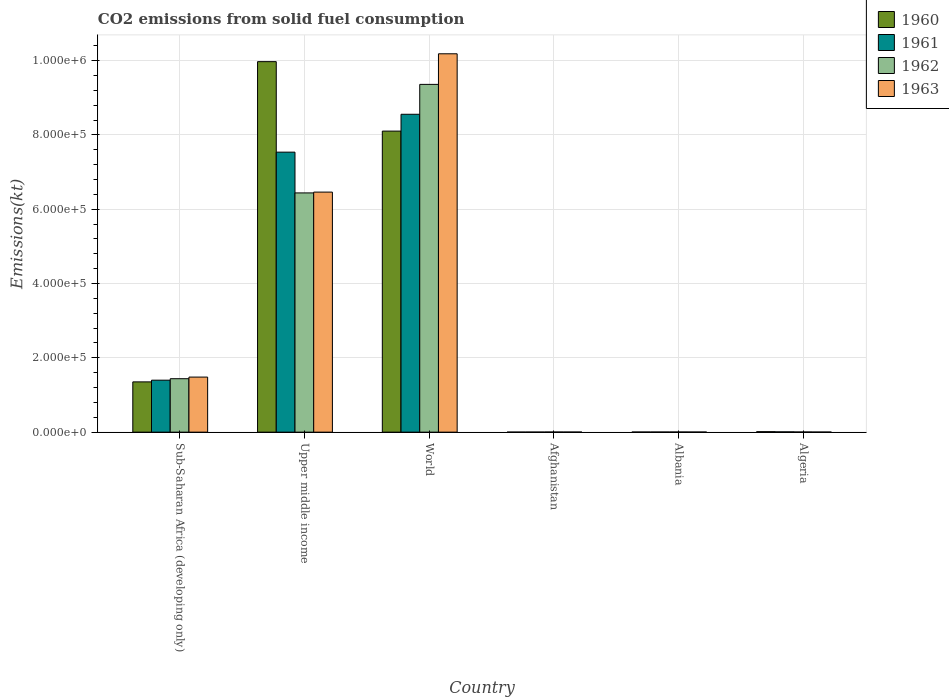How many bars are there on the 5th tick from the left?
Make the answer very short. 4. In how many cases, is the number of bars for a given country not equal to the number of legend labels?
Your answer should be compact. 0. What is the amount of CO2 emitted in 1962 in Upper middle income?
Make the answer very short. 6.44e+05. Across all countries, what is the maximum amount of CO2 emitted in 1961?
Make the answer very short. 8.56e+05. Across all countries, what is the minimum amount of CO2 emitted in 1962?
Your answer should be very brief. 297.03. In which country was the amount of CO2 emitted in 1960 maximum?
Offer a terse response. Upper middle income. In which country was the amount of CO2 emitted in 1963 minimum?
Your response must be concise. Algeria. What is the total amount of CO2 emitted in 1960 in the graph?
Offer a very short reply. 1.94e+06. What is the difference between the amount of CO2 emitted in 1960 in Albania and that in Sub-Saharan Africa (developing only)?
Your answer should be compact. -1.35e+05. What is the difference between the amount of CO2 emitted in 1962 in Afghanistan and the amount of CO2 emitted in 1963 in Algeria?
Give a very brief answer. 44. What is the average amount of CO2 emitted in 1960 per country?
Make the answer very short. 3.24e+05. What is the difference between the amount of CO2 emitted of/in 1961 and amount of CO2 emitted of/in 1963 in Afghanistan?
Your response must be concise. -88.01. What is the ratio of the amount of CO2 emitted in 1960 in Albania to that in Upper middle income?
Offer a very short reply. 0. Is the amount of CO2 emitted in 1961 in Algeria less than that in Sub-Saharan Africa (developing only)?
Your answer should be compact. Yes. What is the difference between the highest and the second highest amount of CO2 emitted in 1962?
Offer a very short reply. 7.92e+05. What is the difference between the highest and the lowest amount of CO2 emitted in 1961?
Your answer should be compact. 8.55e+05. In how many countries, is the amount of CO2 emitted in 1960 greater than the average amount of CO2 emitted in 1960 taken over all countries?
Your response must be concise. 2. Is the sum of the amount of CO2 emitted in 1961 in Albania and World greater than the maximum amount of CO2 emitted in 1963 across all countries?
Make the answer very short. No. Is it the case that in every country, the sum of the amount of CO2 emitted in 1962 and amount of CO2 emitted in 1963 is greater than the sum of amount of CO2 emitted in 1961 and amount of CO2 emitted in 1960?
Offer a terse response. No. What does the 4th bar from the left in Upper middle income represents?
Give a very brief answer. 1963. What does the 3rd bar from the right in Upper middle income represents?
Give a very brief answer. 1961. How many bars are there?
Provide a succinct answer. 24. How many countries are there in the graph?
Give a very brief answer. 6. How many legend labels are there?
Provide a succinct answer. 4. What is the title of the graph?
Make the answer very short. CO2 emissions from solid fuel consumption. What is the label or title of the Y-axis?
Provide a succinct answer. Emissions(kt). What is the Emissions(kt) in 1960 in Sub-Saharan Africa (developing only)?
Your answer should be very brief. 1.35e+05. What is the Emissions(kt) in 1961 in Sub-Saharan Africa (developing only)?
Provide a succinct answer. 1.40e+05. What is the Emissions(kt) in 1962 in Sub-Saharan Africa (developing only)?
Your response must be concise. 1.44e+05. What is the Emissions(kt) of 1963 in Sub-Saharan Africa (developing only)?
Your answer should be compact. 1.48e+05. What is the Emissions(kt) in 1960 in Upper middle income?
Keep it short and to the point. 9.97e+05. What is the Emissions(kt) of 1961 in Upper middle income?
Give a very brief answer. 7.54e+05. What is the Emissions(kt) in 1962 in Upper middle income?
Ensure brevity in your answer.  6.44e+05. What is the Emissions(kt) in 1963 in Upper middle income?
Make the answer very short. 6.46e+05. What is the Emissions(kt) of 1960 in World?
Your answer should be very brief. 8.10e+05. What is the Emissions(kt) in 1961 in World?
Your answer should be very brief. 8.56e+05. What is the Emissions(kt) in 1962 in World?
Provide a succinct answer. 9.36e+05. What is the Emissions(kt) of 1963 in World?
Offer a terse response. 1.02e+06. What is the Emissions(kt) of 1960 in Afghanistan?
Ensure brevity in your answer.  128.34. What is the Emissions(kt) in 1961 in Afghanistan?
Provide a short and direct response. 176.02. What is the Emissions(kt) in 1962 in Afghanistan?
Offer a very short reply. 297.03. What is the Emissions(kt) in 1963 in Afghanistan?
Make the answer very short. 264.02. What is the Emissions(kt) in 1960 in Albania?
Offer a very short reply. 326.36. What is the Emissions(kt) of 1961 in Albania?
Offer a terse response. 322.7. What is the Emissions(kt) in 1962 in Albania?
Provide a succinct answer. 363.03. What is the Emissions(kt) in 1963 in Albania?
Your answer should be very brief. 282.36. What is the Emissions(kt) in 1960 in Algeria?
Offer a very short reply. 1257.78. What is the Emissions(kt) in 1961 in Algeria?
Provide a succinct answer. 766.4. What is the Emissions(kt) in 1962 in Algeria?
Offer a terse response. 407.04. What is the Emissions(kt) in 1963 in Algeria?
Your answer should be very brief. 253.02. Across all countries, what is the maximum Emissions(kt) of 1960?
Make the answer very short. 9.97e+05. Across all countries, what is the maximum Emissions(kt) in 1961?
Offer a terse response. 8.56e+05. Across all countries, what is the maximum Emissions(kt) of 1962?
Offer a terse response. 9.36e+05. Across all countries, what is the maximum Emissions(kt) of 1963?
Offer a terse response. 1.02e+06. Across all countries, what is the minimum Emissions(kt) of 1960?
Provide a short and direct response. 128.34. Across all countries, what is the minimum Emissions(kt) of 1961?
Make the answer very short. 176.02. Across all countries, what is the minimum Emissions(kt) of 1962?
Your answer should be very brief. 297.03. Across all countries, what is the minimum Emissions(kt) in 1963?
Your answer should be compact. 253.02. What is the total Emissions(kt) of 1960 in the graph?
Your response must be concise. 1.94e+06. What is the total Emissions(kt) of 1961 in the graph?
Your response must be concise. 1.75e+06. What is the total Emissions(kt) of 1962 in the graph?
Offer a very short reply. 1.72e+06. What is the total Emissions(kt) in 1963 in the graph?
Offer a very short reply. 1.81e+06. What is the difference between the Emissions(kt) in 1960 in Sub-Saharan Africa (developing only) and that in Upper middle income?
Your answer should be very brief. -8.62e+05. What is the difference between the Emissions(kt) in 1961 in Sub-Saharan Africa (developing only) and that in Upper middle income?
Provide a short and direct response. -6.14e+05. What is the difference between the Emissions(kt) of 1962 in Sub-Saharan Africa (developing only) and that in Upper middle income?
Offer a terse response. -5.00e+05. What is the difference between the Emissions(kt) of 1963 in Sub-Saharan Africa (developing only) and that in Upper middle income?
Offer a very short reply. -4.98e+05. What is the difference between the Emissions(kt) of 1960 in Sub-Saharan Africa (developing only) and that in World?
Offer a terse response. -6.75e+05. What is the difference between the Emissions(kt) of 1961 in Sub-Saharan Africa (developing only) and that in World?
Give a very brief answer. -7.16e+05. What is the difference between the Emissions(kt) in 1962 in Sub-Saharan Africa (developing only) and that in World?
Offer a very short reply. -7.92e+05. What is the difference between the Emissions(kt) of 1963 in Sub-Saharan Africa (developing only) and that in World?
Ensure brevity in your answer.  -8.70e+05. What is the difference between the Emissions(kt) in 1960 in Sub-Saharan Africa (developing only) and that in Afghanistan?
Your answer should be very brief. 1.35e+05. What is the difference between the Emissions(kt) of 1961 in Sub-Saharan Africa (developing only) and that in Afghanistan?
Give a very brief answer. 1.40e+05. What is the difference between the Emissions(kt) in 1962 in Sub-Saharan Africa (developing only) and that in Afghanistan?
Your response must be concise. 1.44e+05. What is the difference between the Emissions(kt) in 1963 in Sub-Saharan Africa (developing only) and that in Afghanistan?
Your response must be concise. 1.48e+05. What is the difference between the Emissions(kt) of 1960 in Sub-Saharan Africa (developing only) and that in Albania?
Offer a terse response. 1.35e+05. What is the difference between the Emissions(kt) in 1961 in Sub-Saharan Africa (developing only) and that in Albania?
Offer a terse response. 1.40e+05. What is the difference between the Emissions(kt) of 1962 in Sub-Saharan Africa (developing only) and that in Albania?
Your answer should be very brief. 1.43e+05. What is the difference between the Emissions(kt) in 1963 in Sub-Saharan Africa (developing only) and that in Albania?
Give a very brief answer. 1.48e+05. What is the difference between the Emissions(kt) in 1960 in Sub-Saharan Africa (developing only) and that in Algeria?
Make the answer very short. 1.34e+05. What is the difference between the Emissions(kt) of 1961 in Sub-Saharan Africa (developing only) and that in Algeria?
Offer a very short reply. 1.39e+05. What is the difference between the Emissions(kt) of 1962 in Sub-Saharan Africa (developing only) and that in Algeria?
Give a very brief answer. 1.43e+05. What is the difference between the Emissions(kt) in 1963 in Sub-Saharan Africa (developing only) and that in Algeria?
Your response must be concise. 1.48e+05. What is the difference between the Emissions(kt) of 1960 in Upper middle income and that in World?
Your response must be concise. 1.87e+05. What is the difference between the Emissions(kt) of 1961 in Upper middle income and that in World?
Offer a terse response. -1.02e+05. What is the difference between the Emissions(kt) in 1962 in Upper middle income and that in World?
Offer a terse response. -2.92e+05. What is the difference between the Emissions(kt) of 1963 in Upper middle income and that in World?
Give a very brief answer. -3.72e+05. What is the difference between the Emissions(kt) in 1960 in Upper middle income and that in Afghanistan?
Your answer should be very brief. 9.97e+05. What is the difference between the Emissions(kt) in 1961 in Upper middle income and that in Afghanistan?
Provide a short and direct response. 7.53e+05. What is the difference between the Emissions(kt) in 1962 in Upper middle income and that in Afghanistan?
Your answer should be very brief. 6.44e+05. What is the difference between the Emissions(kt) in 1963 in Upper middle income and that in Afghanistan?
Ensure brevity in your answer.  6.46e+05. What is the difference between the Emissions(kt) in 1960 in Upper middle income and that in Albania?
Provide a short and direct response. 9.97e+05. What is the difference between the Emissions(kt) of 1961 in Upper middle income and that in Albania?
Offer a very short reply. 7.53e+05. What is the difference between the Emissions(kt) of 1962 in Upper middle income and that in Albania?
Provide a succinct answer. 6.44e+05. What is the difference between the Emissions(kt) in 1963 in Upper middle income and that in Albania?
Offer a very short reply. 6.46e+05. What is the difference between the Emissions(kt) in 1960 in Upper middle income and that in Algeria?
Offer a terse response. 9.96e+05. What is the difference between the Emissions(kt) of 1961 in Upper middle income and that in Algeria?
Your answer should be very brief. 7.53e+05. What is the difference between the Emissions(kt) of 1962 in Upper middle income and that in Algeria?
Offer a terse response. 6.44e+05. What is the difference between the Emissions(kt) in 1963 in Upper middle income and that in Algeria?
Ensure brevity in your answer.  6.46e+05. What is the difference between the Emissions(kt) of 1960 in World and that in Afghanistan?
Offer a terse response. 8.10e+05. What is the difference between the Emissions(kt) of 1961 in World and that in Afghanistan?
Offer a very short reply. 8.55e+05. What is the difference between the Emissions(kt) of 1962 in World and that in Afghanistan?
Give a very brief answer. 9.36e+05. What is the difference between the Emissions(kt) of 1963 in World and that in Afghanistan?
Offer a very short reply. 1.02e+06. What is the difference between the Emissions(kt) in 1960 in World and that in Albania?
Offer a terse response. 8.10e+05. What is the difference between the Emissions(kt) in 1961 in World and that in Albania?
Offer a terse response. 8.55e+05. What is the difference between the Emissions(kt) of 1962 in World and that in Albania?
Give a very brief answer. 9.36e+05. What is the difference between the Emissions(kt) of 1963 in World and that in Albania?
Keep it short and to the point. 1.02e+06. What is the difference between the Emissions(kt) of 1960 in World and that in Algeria?
Provide a succinct answer. 8.09e+05. What is the difference between the Emissions(kt) of 1961 in World and that in Algeria?
Your answer should be very brief. 8.55e+05. What is the difference between the Emissions(kt) in 1962 in World and that in Algeria?
Provide a short and direct response. 9.36e+05. What is the difference between the Emissions(kt) of 1963 in World and that in Algeria?
Your answer should be compact. 1.02e+06. What is the difference between the Emissions(kt) of 1960 in Afghanistan and that in Albania?
Keep it short and to the point. -198.02. What is the difference between the Emissions(kt) of 1961 in Afghanistan and that in Albania?
Your response must be concise. -146.68. What is the difference between the Emissions(kt) in 1962 in Afghanistan and that in Albania?
Your answer should be compact. -66.01. What is the difference between the Emissions(kt) of 1963 in Afghanistan and that in Albania?
Your answer should be compact. -18.34. What is the difference between the Emissions(kt) in 1960 in Afghanistan and that in Algeria?
Ensure brevity in your answer.  -1129.44. What is the difference between the Emissions(kt) of 1961 in Afghanistan and that in Algeria?
Give a very brief answer. -590.39. What is the difference between the Emissions(kt) of 1962 in Afghanistan and that in Algeria?
Your answer should be very brief. -110.01. What is the difference between the Emissions(kt) in 1963 in Afghanistan and that in Algeria?
Give a very brief answer. 11. What is the difference between the Emissions(kt) in 1960 in Albania and that in Algeria?
Make the answer very short. -931.42. What is the difference between the Emissions(kt) in 1961 in Albania and that in Algeria?
Provide a succinct answer. -443.71. What is the difference between the Emissions(kt) in 1962 in Albania and that in Algeria?
Your answer should be very brief. -44. What is the difference between the Emissions(kt) of 1963 in Albania and that in Algeria?
Keep it short and to the point. 29.34. What is the difference between the Emissions(kt) in 1960 in Sub-Saharan Africa (developing only) and the Emissions(kt) in 1961 in Upper middle income?
Offer a terse response. -6.18e+05. What is the difference between the Emissions(kt) in 1960 in Sub-Saharan Africa (developing only) and the Emissions(kt) in 1962 in Upper middle income?
Keep it short and to the point. -5.09e+05. What is the difference between the Emissions(kt) in 1960 in Sub-Saharan Africa (developing only) and the Emissions(kt) in 1963 in Upper middle income?
Provide a succinct answer. -5.11e+05. What is the difference between the Emissions(kt) in 1961 in Sub-Saharan Africa (developing only) and the Emissions(kt) in 1962 in Upper middle income?
Your answer should be compact. -5.04e+05. What is the difference between the Emissions(kt) in 1961 in Sub-Saharan Africa (developing only) and the Emissions(kt) in 1963 in Upper middle income?
Ensure brevity in your answer.  -5.06e+05. What is the difference between the Emissions(kt) of 1962 in Sub-Saharan Africa (developing only) and the Emissions(kt) of 1963 in Upper middle income?
Your answer should be compact. -5.02e+05. What is the difference between the Emissions(kt) in 1960 in Sub-Saharan Africa (developing only) and the Emissions(kt) in 1961 in World?
Ensure brevity in your answer.  -7.20e+05. What is the difference between the Emissions(kt) in 1960 in Sub-Saharan Africa (developing only) and the Emissions(kt) in 1962 in World?
Your response must be concise. -8.01e+05. What is the difference between the Emissions(kt) of 1960 in Sub-Saharan Africa (developing only) and the Emissions(kt) of 1963 in World?
Offer a very short reply. -8.83e+05. What is the difference between the Emissions(kt) of 1961 in Sub-Saharan Africa (developing only) and the Emissions(kt) of 1962 in World?
Keep it short and to the point. -7.96e+05. What is the difference between the Emissions(kt) in 1961 in Sub-Saharan Africa (developing only) and the Emissions(kt) in 1963 in World?
Provide a succinct answer. -8.79e+05. What is the difference between the Emissions(kt) in 1962 in Sub-Saharan Africa (developing only) and the Emissions(kt) in 1963 in World?
Keep it short and to the point. -8.75e+05. What is the difference between the Emissions(kt) in 1960 in Sub-Saharan Africa (developing only) and the Emissions(kt) in 1961 in Afghanistan?
Offer a very short reply. 1.35e+05. What is the difference between the Emissions(kt) of 1960 in Sub-Saharan Africa (developing only) and the Emissions(kt) of 1962 in Afghanistan?
Give a very brief answer. 1.35e+05. What is the difference between the Emissions(kt) in 1960 in Sub-Saharan Africa (developing only) and the Emissions(kt) in 1963 in Afghanistan?
Your response must be concise. 1.35e+05. What is the difference between the Emissions(kt) in 1961 in Sub-Saharan Africa (developing only) and the Emissions(kt) in 1962 in Afghanistan?
Your answer should be compact. 1.40e+05. What is the difference between the Emissions(kt) of 1961 in Sub-Saharan Africa (developing only) and the Emissions(kt) of 1963 in Afghanistan?
Your answer should be very brief. 1.40e+05. What is the difference between the Emissions(kt) of 1962 in Sub-Saharan Africa (developing only) and the Emissions(kt) of 1963 in Afghanistan?
Ensure brevity in your answer.  1.44e+05. What is the difference between the Emissions(kt) in 1960 in Sub-Saharan Africa (developing only) and the Emissions(kt) in 1961 in Albania?
Provide a short and direct response. 1.35e+05. What is the difference between the Emissions(kt) in 1960 in Sub-Saharan Africa (developing only) and the Emissions(kt) in 1962 in Albania?
Provide a short and direct response. 1.35e+05. What is the difference between the Emissions(kt) in 1960 in Sub-Saharan Africa (developing only) and the Emissions(kt) in 1963 in Albania?
Your answer should be very brief. 1.35e+05. What is the difference between the Emissions(kt) of 1961 in Sub-Saharan Africa (developing only) and the Emissions(kt) of 1962 in Albania?
Keep it short and to the point. 1.40e+05. What is the difference between the Emissions(kt) of 1961 in Sub-Saharan Africa (developing only) and the Emissions(kt) of 1963 in Albania?
Give a very brief answer. 1.40e+05. What is the difference between the Emissions(kt) of 1962 in Sub-Saharan Africa (developing only) and the Emissions(kt) of 1963 in Albania?
Make the answer very short. 1.44e+05. What is the difference between the Emissions(kt) in 1960 in Sub-Saharan Africa (developing only) and the Emissions(kt) in 1961 in Algeria?
Your response must be concise. 1.35e+05. What is the difference between the Emissions(kt) of 1960 in Sub-Saharan Africa (developing only) and the Emissions(kt) of 1962 in Algeria?
Ensure brevity in your answer.  1.35e+05. What is the difference between the Emissions(kt) of 1960 in Sub-Saharan Africa (developing only) and the Emissions(kt) of 1963 in Algeria?
Ensure brevity in your answer.  1.35e+05. What is the difference between the Emissions(kt) in 1961 in Sub-Saharan Africa (developing only) and the Emissions(kt) in 1962 in Algeria?
Provide a short and direct response. 1.39e+05. What is the difference between the Emissions(kt) of 1961 in Sub-Saharan Africa (developing only) and the Emissions(kt) of 1963 in Algeria?
Your answer should be compact. 1.40e+05. What is the difference between the Emissions(kt) of 1962 in Sub-Saharan Africa (developing only) and the Emissions(kt) of 1963 in Algeria?
Make the answer very short. 1.44e+05. What is the difference between the Emissions(kt) in 1960 in Upper middle income and the Emissions(kt) in 1961 in World?
Offer a very short reply. 1.42e+05. What is the difference between the Emissions(kt) in 1960 in Upper middle income and the Emissions(kt) in 1962 in World?
Your answer should be compact. 6.12e+04. What is the difference between the Emissions(kt) of 1960 in Upper middle income and the Emissions(kt) of 1963 in World?
Offer a terse response. -2.12e+04. What is the difference between the Emissions(kt) in 1961 in Upper middle income and the Emissions(kt) in 1962 in World?
Offer a very short reply. -1.82e+05. What is the difference between the Emissions(kt) of 1961 in Upper middle income and the Emissions(kt) of 1963 in World?
Provide a short and direct response. -2.65e+05. What is the difference between the Emissions(kt) in 1962 in Upper middle income and the Emissions(kt) in 1963 in World?
Provide a succinct answer. -3.74e+05. What is the difference between the Emissions(kt) in 1960 in Upper middle income and the Emissions(kt) in 1961 in Afghanistan?
Your answer should be very brief. 9.97e+05. What is the difference between the Emissions(kt) of 1960 in Upper middle income and the Emissions(kt) of 1962 in Afghanistan?
Offer a very short reply. 9.97e+05. What is the difference between the Emissions(kt) in 1960 in Upper middle income and the Emissions(kt) in 1963 in Afghanistan?
Give a very brief answer. 9.97e+05. What is the difference between the Emissions(kt) of 1961 in Upper middle income and the Emissions(kt) of 1962 in Afghanistan?
Give a very brief answer. 7.53e+05. What is the difference between the Emissions(kt) of 1961 in Upper middle income and the Emissions(kt) of 1963 in Afghanistan?
Your answer should be very brief. 7.53e+05. What is the difference between the Emissions(kt) in 1962 in Upper middle income and the Emissions(kt) in 1963 in Afghanistan?
Offer a very short reply. 6.44e+05. What is the difference between the Emissions(kt) in 1960 in Upper middle income and the Emissions(kt) in 1961 in Albania?
Your answer should be compact. 9.97e+05. What is the difference between the Emissions(kt) in 1960 in Upper middle income and the Emissions(kt) in 1962 in Albania?
Give a very brief answer. 9.97e+05. What is the difference between the Emissions(kt) of 1960 in Upper middle income and the Emissions(kt) of 1963 in Albania?
Your answer should be compact. 9.97e+05. What is the difference between the Emissions(kt) in 1961 in Upper middle income and the Emissions(kt) in 1962 in Albania?
Your answer should be very brief. 7.53e+05. What is the difference between the Emissions(kt) in 1961 in Upper middle income and the Emissions(kt) in 1963 in Albania?
Provide a short and direct response. 7.53e+05. What is the difference between the Emissions(kt) in 1962 in Upper middle income and the Emissions(kt) in 1963 in Albania?
Offer a terse response. 6.44e+05. What is the difference between the Emissions(kt) of 1960 in Upper middle income and the Emissions(kt) of 1961 in Algeria?
Ensure brevity in your answer.  9.97e+05. What is the difference between the Emissions(kt) in 1960 in Upper middle income and the Emissions(kt) in 1962 in Algeria?
Keep it short and to the point. 9.97e+05. What is the difference between the Emissions(kt) of 1960 in Upper middle income and the Emissions(kt) of 1963 in Algeria?
Provide a succinct answer. 9.97e+05. What is the difference between the Emissions(kt) of 1961 in Upper middle income and the Emissions(kt) of 1962 in Algeria?
Ensure brevity in your answer.  7.53e+05. What is the difference between the Emissions(kt) of 1961 in Upper middle income and the Emissions(kt) of 1963 in Algeria?
Keep it short and to the point. 7.53e+05. What is the difference between the Emissions(kt) in 1962 in Upper middle income and the Emissions(kt) in 1963 in Algeria?
Make the answer very short. 6.44e+05. What is the difference between the Emissions(kt) in 1960 in World and the Emissions(kt) in 1961 in Afghanistan?
Provide a succinct answer. 8.10e+05. What is the difference between the Emissions(kt) in 1960 in World and the Emissions(kt) in 1962 in Afghanistan?
Provide a succinct answer. 8.10e+05. What is the difference between the Emissions(kt) of 1960 in World and the Emissions(kt) of 1963 in Afghanistan?
Make the answer very short. 8.10e+05. What is the difference between the Emissions(kt) of 1961 in World and the Emissions(kt) of 1962 in Afghanistan?
Provide a short and direct response. 8.55e+05. What is the difference between the Emissions(kt) of 1961 in World and the Emissions(kt) of 1963 in Afghanistan?
Your answer should be very brief. 8.55e+05. What is the difference between the Emissions(kt) in 1962 in World and the Emissions(kt) in 1963 in Afghanistan?
Give a very brief answer. 9.36e+05. What is the difference between the Emissions(kt) in 1960 in World and the Emissions(kt) in 1961 in Albania?
Keep it short and to the point. 8.10e+05. What is the difference between the Emissions(kt) in 1960 in World and the Emissions(kt) in 1962 in Albania?
Your response must be concise. 8.10e+05. What is the difference between the Emissions(kt) in 1960 in World and the Emissions(kt) in 1963 in Albania?
Make the answer very short. 8.10e+05. What is the difference between the Emissions(kt) of 1961 in World and the Emissions(kt) of 1962 in Albania?
Your answer should be compact. 8.55e+05. What is the difference between the Emissions(kt) of 1961 in World and the Emissions(kt) of 1963 in Albania?
Ensure brevity in your answer.  8.55e+05. What is the difference between the Emissions(kt) of 1962 in World and the Emissions(kt) of 1963 in Albania?
Give a very brief answer. 9.36e+05. What is the difference between the Emissions(kt) in 1960 in World and the Emissions(kt) in 1961 in Algeria?
Offer a terse response. 8.10e+05. What is the difference between the Emissions(kt) of 1960 in World and the Emissions(kt) of 1962 in Algeria?
Provide a short and direct response. 8.10e+05. What is the difference between the Emissions(kt) in 1960 in World and the Emissions(kt) in 1963 in Algeria?
Provide a short and direct response. 8.10e+05. What is the difference between the Emissions(kt) in 1961 in World and the Emissions(kt) in 1962 in Algeria?
Keep it short and to the point. 8.55e+05. What is the difference between the Emissions(kt) in 1961 in World and the Emissions(kt) in 1963 in Algeria?
Provide a succinct answer. 8.55e+05. What is the difference between the Emissions(kt) in 1962 in World and the Emissions(kt) in 1963 in Algeria?
Your answer should be very brief. 9.36e+05. What is the difference between the Emissions(kt) of 1960 in Afghanistan and the Emissions(kt) of 1961 in Albania?
Offer a terse response. -194.35. What is the difference between the Emissions(kt) in 1960 in Afghanistan and the Emissions(kt) in 1962 in Albania?
Offer a terse response. -234.69. What is the difference between the Emissions(kt) in 1960 in Afghanistan and the Emissions(kt) in 1963 in Albania?
Offer a terse response. -154.01. What is the difference between the Emissions(kt) of 1961 in Afghanistan and the Emissions(kt) of 1962 in Albania?
Make the answer very short. -187.02. What is the difference between the Emissions(kt) in 1961 in Afghanistan and the Emissions(kt) in 1963 in Albania?
Ensure brevity in your answer.  -106.34. What is the difference between the Emissions(kt) of 1962 in Afghanistan and the Emissions(kt) of 1963 in Albania?
Your response must be concise. 14.67. What is the difference between the Emissions(kt) in 1960 in Afghanistan and the Emissions(kt) in 1961 in Algeria?
Keep it short and to the point. -638.06. What is the difference between the Emissions(kt) of 1960 in Afghanistan and the Emissions(kt) of 1962 in Algeria?
Your answer should be compact. -278.69. What is the difference between the Emissions(kt) in 1960 in Afghanistan and the Emissions(kt) in 1963 in Algeria?
Offer a very short reply. -124.68. What is the difference between the Emissions(kt) of 1961 in Afghanistan and the Emissions(kt) of 1962 in Algeria?
Offer a terse response. -231.02. What is the difference between the Emissions(kt) of 1961 in Afghanistan and the Emissions(kt) of 1963 in Algeria?
Your answer should be very brief. -77.01. What is the difference between the Emissions(kt) of 1962 in Afghanistan and the Emissions(kt) of 1963 in Algeria?
Provide a succinct answer. 44. What is the difference between the Emissions(kt) of 1960 in Albania and the Emissions(kt) of 1961 in Algeria?
Offer a terse response. -440.04. What is the difference between the Emissions(kt) in 1960 in Albania and the Emissions(kt) in 1962 in Algeria?
Make the answer very short. -80.67. What is the difference between the Emissions(kt) in 1960 in Albania and the Emissions(kt) in 1963 in Algeria?
Provide a succinct answer. 73.34. What is the difference between the Emissions(kt) in 1961 in Albania and the Emissions(kt) in 1962 in Algeria?
Provide a short and direct response. -84.34. What is the difference between the Emissions(kt) of 1961 in Albania and the Emissions(kt) of 1963 in Algeria?
Give a very brief answer. 69.67. What is the difference between the Emissions(kt) in 1962 in Albania and the Emissions(kt) in 1963 in Algeria?
Offer a terse response. 110.01. What is the average Emissions(kt) of 1960 per country?
Ensure brevity in your answer.  3.24e+05. What is the average Emissions(kt) in 1961 per country?
Your answer should be very brief. 2.92e+05. What is the average Emissions(kt) in 1962 per country?
Offer a very short reply. 2.87e+05. What is the average Emissions(kt) in 1963 per country?
Give a very brief answer. 3.02e+05. What is the difference between the Emissions(kt) of 1960 and Emissions(kt) of 1961 in Sub-Saharan Africa (developing only)?
Your answer should be compact. -4582.5. What is the difference between the Emissions(kt) in 1960 and Emissions(kt) in 1962 in Sub-Saharan Africa (developing only)?
Provide a short and direct response. -8539.18. What is the difference between the Emissions(kt) of 1960 and Emissions(kt) of 1963 in Sub-Saharan Africa (developing only)?
Your response must be concise. -1.29e+04. What is the difference between the Emissions(kt) of 1961 and Emissions(kt) of 1962 in Sub-Saharan Africa (developing only)?
Your answer should be very brief. -3956.69. What is the difference between the Emissions(kt) of 1961 and Emissions(kt) of 1963 in Sub-Saharan Africa (developing only)?
Give a very brief answer. -8302.03. What is the difference between the Emissions(kt) of 1962 and Emissions(kt) of 1963 in Sub-Saharan Africa (developing only)?
Provide a short and direct response. -4345.34. What is the difference between the Emissions(kt) of 1960 and Emissions(kt) of 1961 in Upper middle income?
Offer a terse response. 2.44e+05. What is the difference between the Emissions(kt) in 1960 and Emissions(kt) in 1962 in Upper middle income?
Provide a short and direct response. 3.53e+05. What is the difference between the Emissions(kt) of 1960 and Emissions(kt) of 1963 in Upper middle income?
Give a very brief answer. 3.51e+05. What is the difference between the Emissions(kt) of 1961 and Emissions(kt) of 1962 in Upper middle income?
Your answer should be compact. 1.10e+05. What is the difference between the Emissions(kt) in 1961 and Emissions(kt) in 1963 in Upper middle income?
Make the answer very short. 1.08e+05. What is the difference between the Emissions(kt) of 1962 and Emissions(kt) of 1963 in Upper middle income?
Give a very brief answer. -2192.22. What is the difference between the Emissions(kt) of 1960 and Emissions(kt) of 1961 in World?
Your answer should be compact. -4.53e+04. What is the difference between the Emissions(kt) in 1960 and Emissions(kt) in 1962 in World?
Offer a terse response. -1.26e+05. What is the difference between the Emissions(kt) in 1960 and Emissions(kt) in 1963 in World?
Provide a succinct answer. -2.08e+05. What is the difference between the Emissions(kt) in 1961 and Emissions(kt) in 1962 in World?
Offer a terse response. -8.05e+04. What is the difference between the Emissions(kt) of 1961 and Emissions(kt) of 1963 in World?
Your answer should be very brief. -1.63e+05. What is the difference between the Emissions(kt) in 1962 and Emissions(kt) in 1963 in World?
Your answer should be compact. -8.24e+04. What is the difference between the Emissions(kt) of 1960 and Emissions(kt) of 1961 in Afghanistan?
Offer a terse response. -47.67. What is the difference between the Emissions(kt) of 1960 and Emissions(kt) of 1962 in Afghanistan?
Your answer should be compact. -168.68. What is the difference between the Emissions(kt) in 1960 and Emissions(kt) in 1963 in Afghanistan?
Your answer should be very brief. -135.68. What is the difference between the Emissions(kt) in 1961 and Emissions(kt) in 1962 in Afghanistan?
Keep it short and to the point. -121.01. What is the difference between the Emissions(kt) in 1961 and Emissions(kt) in 1963 in Afghanistan?
Provide a short and direct response. -88.01. What is the difference between the Emissions(kt) in 1962 and Emissions(kt) in 1963 in Afghanistan?
Ensure brevity in your answer.  33. What is the difference between the Emissions(kt) in 1960 and Emissions(kt) in 1961 in Albania?
Offer a very short reply. 3.67. What is the difference between the Emissions(kt) in 1960 and Emissions(kt) in 1962 in Albania?
Offer a very short reply. -36.67. What is the difference between the Emissions(kt) of 1960 and Emissions(kt) of 1963 in Albania?
Offer a terse response. 44. What is the difference between the Emissions(kt) of 1961 and Emissions(kt) of 1962 in Albania?
Your response must be concise. -40.34. What is the difference between the Emissions(kt) of 1961 and Emissions(kt) of 1963 in Albania?
Offer a terse response. 40.34. What is the difference between the Emissions(kt) of 1962 and Emissions(kt) of 1963 in Albania?
Your answer should be very brief. 80.67. What is the difference between the Emissions(kt) of 1960 and Emissions(kt) of 1961 in Algeria?
Give a very brief answer. 491.38. What is the difference between the Emissions(kt) in 1960 and Emissions(kt) in 1962 in Algeria?
Ensure brevity in your answer.  850.74. What is the difference between the Emissions(kt) in 1960 and Emissions(kt) in 1963 in Algeria?
Your answer should be compact. 1004.76. What is the difference between the Emissions(kt) in 1961 and Emissions(kt) in 1962 in Algeria?
Keep it short and to the point. 359.37. What is the difference between the Emissions(kt) in 1961 and Emissions(kt) in 1963 in Algeria?
Provide a succinct answer. 513.38. What is the difference between the Emissions(kt) of 1962 and Emissions(kt) of 1963 in Algeria?
Your answer should be compact. 154.01. What is the ratio of the Emissions(kt) of 1960 in Sub-Saharan Africa (developing only) to that in Upper middle income?
Provide a short and direct response. 0.14. What is the ratio of the Emissions(kt) in 1961 in Sub-Saharan Africa (developing only) to that in Upper middle income?
Offer a very short reply. 0.19. What is the ratio of the Emissions(kt) of 1962 in Sub-Saharan Africa (developing only) to that in Upper middle income?
Your answer should be very brief. 0.22. What is the ratio of the Emissions(kt) of 1963 in Sub-Saharan Africa (developing only) to that in Upper middle income?
Ensure brevity in your answer.  0.23. What is the ratio of the Emissions(kt) of 1960 in Sub-Saharan Africa (developing only) to that in World?
Offer a very short reply. 0.17. What is the ratio of the Emissions(kt) in 1961 in Sub-Saharan Africa (developing only) to that in World?
Your answer should be compact. 0.16. What is the ratio of the Emissions(kt) of 1962 in Sub-Saharan Africa (developing only) to that in World?
Make the answer very short. 0.15. What is the ratio of the Emissions(kt) in 1963 in Sub-Saharan Africa (developing only) to that in World?
Your answer should be compact. 0.15. What is the ratio of the Emissions(kt) in 1960 in Sub-Saharan Africa (developing only) to that in Afghanistan?
Offer a terse response. 1054.27. What is the ratio of the Emissions(kt) of 1961 in Sub-Saharan Africa (developing only) to that in Afghanistan?
Offer a terse response. 794.77. What is the ratio of the Emissions(kt) of 1962 in Sub-Saharan Africa (developing only) to that in Afghanistan?
Your answer should be compact. 484.3. What is the ratio of the Emissions(kt) in 1963 in Sub-Saharan Africa (developing only) to that in Afghanistan?
Your response must be concise. 561.29. What is the ratio of the Emissions(kt) in 1960 in Sub-Saharan Africa (developing only) to that in Albania?
Keep it short and to the point. 414.6. What is the ratio of the Emissions(kt) in 1961 in Sub-Saharan Africa (developing only) to that in Albania?
Your answer should be very brief. 433.51. What is the ratio of the Emissions(kt) of 1962 in Sub-Saharan Africa (developing only) to that in Albania?
Keep it short and to the point. 396.24. What is the ratio of the Emissions(kt) in 1963 in Sub-Saharan Africa (developing only) to that in Albania?
Your response must be concise. 524.85. What is the ratio of the Emissions(kt) of 1960 in Sub-Saharan Africa (developing only) to that in Algeria?
Offer a terse response. 107.58. What is the ratio of the Emissions(kt) of 1961 in Sub-Saharan Africa (developing only) to that in Algeria?
Offer a very short reply. 182.53. What is the ratio of the Emissions(kt) in 1962 in Sub-Saharan Africa (developing only) to that in Algeria?
Offer a very short reply. 353.41. What is the ratio of the Emissions(kt) of 1963 in Sub-Saharan Africa (developing only) to that in Algeria?
Make the answer very short. 585.7. What is the ratio of the Emissions(kt) in 1960 in Upper middle income to that in World?
Make the answer very short. 1.23. What is the ratio of the Emissions(kt) in 1961 in Upper middle income to that in World?
Provide a succinct answer. 0.88. What is the ratio of the Emissions(kt) in 1962 in Upper middle income to that in World?
Give a very brief answer. 0.69. What is the ratio of the Emissions(kt) in 1963 in Upper middle income to that in World?
Your response must be concise. 0.63. What is the ratio of the Emissions(kt) of 1960 in Upper middle income to that in Afghanistan?
Provide a succinct answer. 7770.2. What is the ratio of the Emissions(kt) of 1961 in Upper middle income to that in Afghanistan?
Make the answer very short. 4281.81. What is the ratio of the Emissions(kt) of 1962 in Upper middle income to that in Afghanistan?
Provide a short and direct response. 2167.93. What is the ratio of the Emissions(kt) in 1963 in Upper middle income to that in Afghanistan?
Your answer should be very brief. 2447.22. What is the ratio of the Emissions(kt) in 1960 in Upper middle income to that in Albania?
Give a very brief answer. 3055.7. What is the ratio of the Emissions(kt) in 1961 in Upper middle income to that in Albania?
Keep it short and to the point. 2335.53. What is the ratio of the Emissions(kt) of 1962 in Upper middle income to that in Albania?
Your answer should be very brief. 1773.76. What is the ratio of the Emissions(kt) of 1963 in Upper middle income to that in Albania?
Ensure brevity in your answer.  2288.31. What is the ratio of the Emissions(kt) of 1960 in Upper middle income to that in Algeria?
Provide a succinct answer. 792.88. What is the ratio of the Emissions(kt) of 1961 in Upper middle income to that in Algeria?
Your answer should be compact. 983.38. What is the ratio of the Emissions(kt) in 1962 in Upper middle income to that in Algeria?
Keep it short and to the point. 1582. What is the ratio of the Emissions(kt) of 1963 in Upper middle income to that in Algeria?
Ensure brevity in your answer.  2553.62. What is the ratio of the Emissions(kt) of 1960 in World to that in Afghanistan?
Give a very brief answer. 6313.69. What is the ratio of the Emissions(kt) in 1961 in World to that in Afghanistan?
Ensure brevity in your answer.  4860.98. What is the ratio of the Emissions(kt) of 1962 in World to that in Afghanistan?
Your answer should be very brief. 3151.44. What is the ratio of the Emissions(kt) in 1963 in World to that in Afghanistan?
Your answer should be compact. 3857.29. What is the ratio of the Emissions(kt) in 1960 in World to that in Albania?
Offer a terse response. 2482.91. What is the ratio of the Emissions(kt) of 1961 in World to that in Albania?
Make the answer very short. 2651.44. What is the ratio of the Emissions(kt) in 1962 in World to that in Albania?
Provide a short and direct response. 2578.45. What is the ratio of the Emissions(kt) of 1963 in World to that in Albania?
Provide a succinct answer. 3606.82. What is the ratio of the Emissions(kt) in 1960 in World to that in Algeria?
Offer a terse response. 644.25. What is the ratio of the Emissions(kt) of 1961 in World to that in Algeria?
Give a very brief answer. 1116.4. What is the ratio of the Emissions(kt) of 1962 in World to that in Algeria?
Ensure brevity in your answer.  2299.7. What is the ratio of the Emissions(kt) of 1963 in World to that in Algeria?
Provide a succinct answer. 4025. What is the ratio of the Emissions(kt) in 1960 in Afghanistan to that in Albania?
Your answer should be compact. 0.39. What is the ratio of the Emissions(kt) in 1961 in Afghanistan to that in Albania?
Make the answer very short. 0.55. What is the ratio of the Emissions(kt) of 1962 in Afghanistan to that in Albania?
Provide a short and direct response. 0.82. What is the ratio of the Emissions(kt) in 1963 in Afghanistan to that in Albania?
Your answer should be compact. 0.94. What is the ratio of the Emissions(kt) of 1960 in Afghanistan to that in Algeria?
Offer a very short reply. 0.1. What is the ratio of the Emissions(kt) in 1961 in Afghanistan to that in Algeria?
Provide a short and direct response. 0.23. What is the ratio of the Emissions(kt) of 1962 in Afghanistan to that in Algeria?
Provide a succinct answer. 0.73. What is the ratio of the Emissions(kt) in 1963 in Afghanistan to that in Algeria?
Ensure brevity in your answer.  1.04. What is the ratio of the Emissions(kt) in 1960 in Albania to that in Algeria?
Your response must be concise. 0.26. What is the ratio of the Emissions(kt) of 1961 in Albania to that in Algeria?
Your response must be concise. 0.42. What is the ratio of the Emissions(kt) in 1962 in Albania to that in Algeria?
Provide a succinct answer. 0.89. What is the ratio of the Emissions(kt) of 1963 in Albania to that in Algeria?
Give a very brief answer. 1.12. What is the difference between the highest and the second highest Emissions(kt) of 1960?
Offer a terse response. 1.87e+05. What is the difference between the highest and the second highest Emissions(kt) in 1961?
Your answer should be compact. 1.02e+05. What is the difference between the highest and the second highest Emissions(kt) in 1962?
Keep it short and to the point. 2.92e+05. What is the difference between the highest and the second highest Emissions(kt) of 1963?
Ensure brevity in your answer.  3.72e+05. What is the difference between the highest and the lowest Emissions(kt) of 1960?
Make the answer very short. 9.97e+05. What is the difference between the highest and the lowest Emissions(kt) in 1961?
Keep it short and to the point. 8.55e+05. What is the difference between the highest and the lowest Emissions(kt) in 1962?
Your answer should be very brief. 9.36e+05. What is the difference between the highest and the lowest Emissions(kt) in 1963?
Offer a terse response. 1.02e+06. 